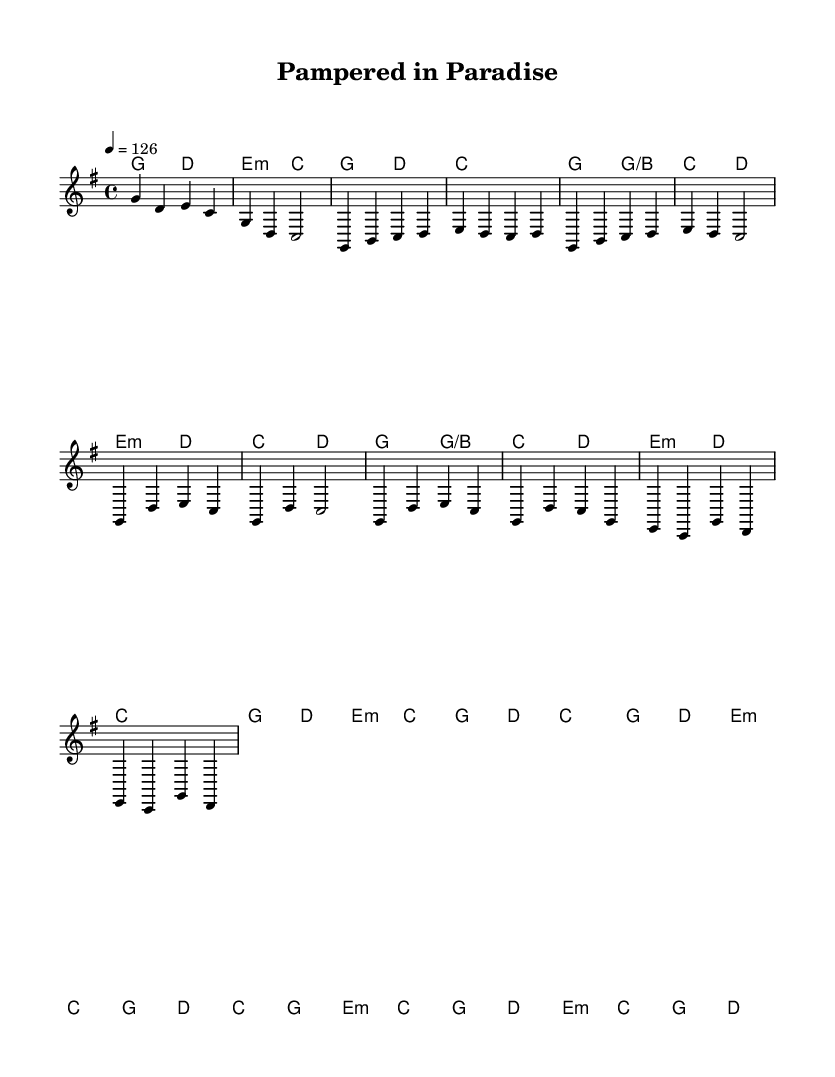What is the key signature of this music? The key signature is G major, which has one sharp (F#). This can be identified by looking at the key signature notation at the beginning of the staff, which indicates the pitch that defines the key.
Answer: G major What is the time signature of this music? The time signature is 4/4, which means there are four beats in each measure and the quarter note gets one beat. This is visible at the beginning of the score, right after the key signature.
Answer: 4/4 What is the tempo marking of this music? The tempo marking is 126 beats per minute, indicated by the notation "4 = 126" at the beginning. This tells performers the speed of the piece, measured in beats per minute.
Answer: 126 Which chord is used most frequently in the chorus section? The chord G major is used most frequently in the chorus, appearing in multiple measures in repetition throughout the chorus section. By analyzing the chord changes listed, G major appears prominently.
Answer: G How many measures are there in the bridge section? There are four measures in the bridge section, as indicated by the grouping of music notes and chord indicators after the chorus. Each section is visually separated by the structure of the music.
Answer: Four What types of feelings does the melody evoke in relation to the theme of luxury and self-care? The melody is upbeat and lively, evoking feelings of joy and celebration. This matches the theme of luxury and self-care as it encourages a positive and uplifting atmosphere. The rhythmic and melodic choices contribute to this overall feeling.
Answer: Joyful 